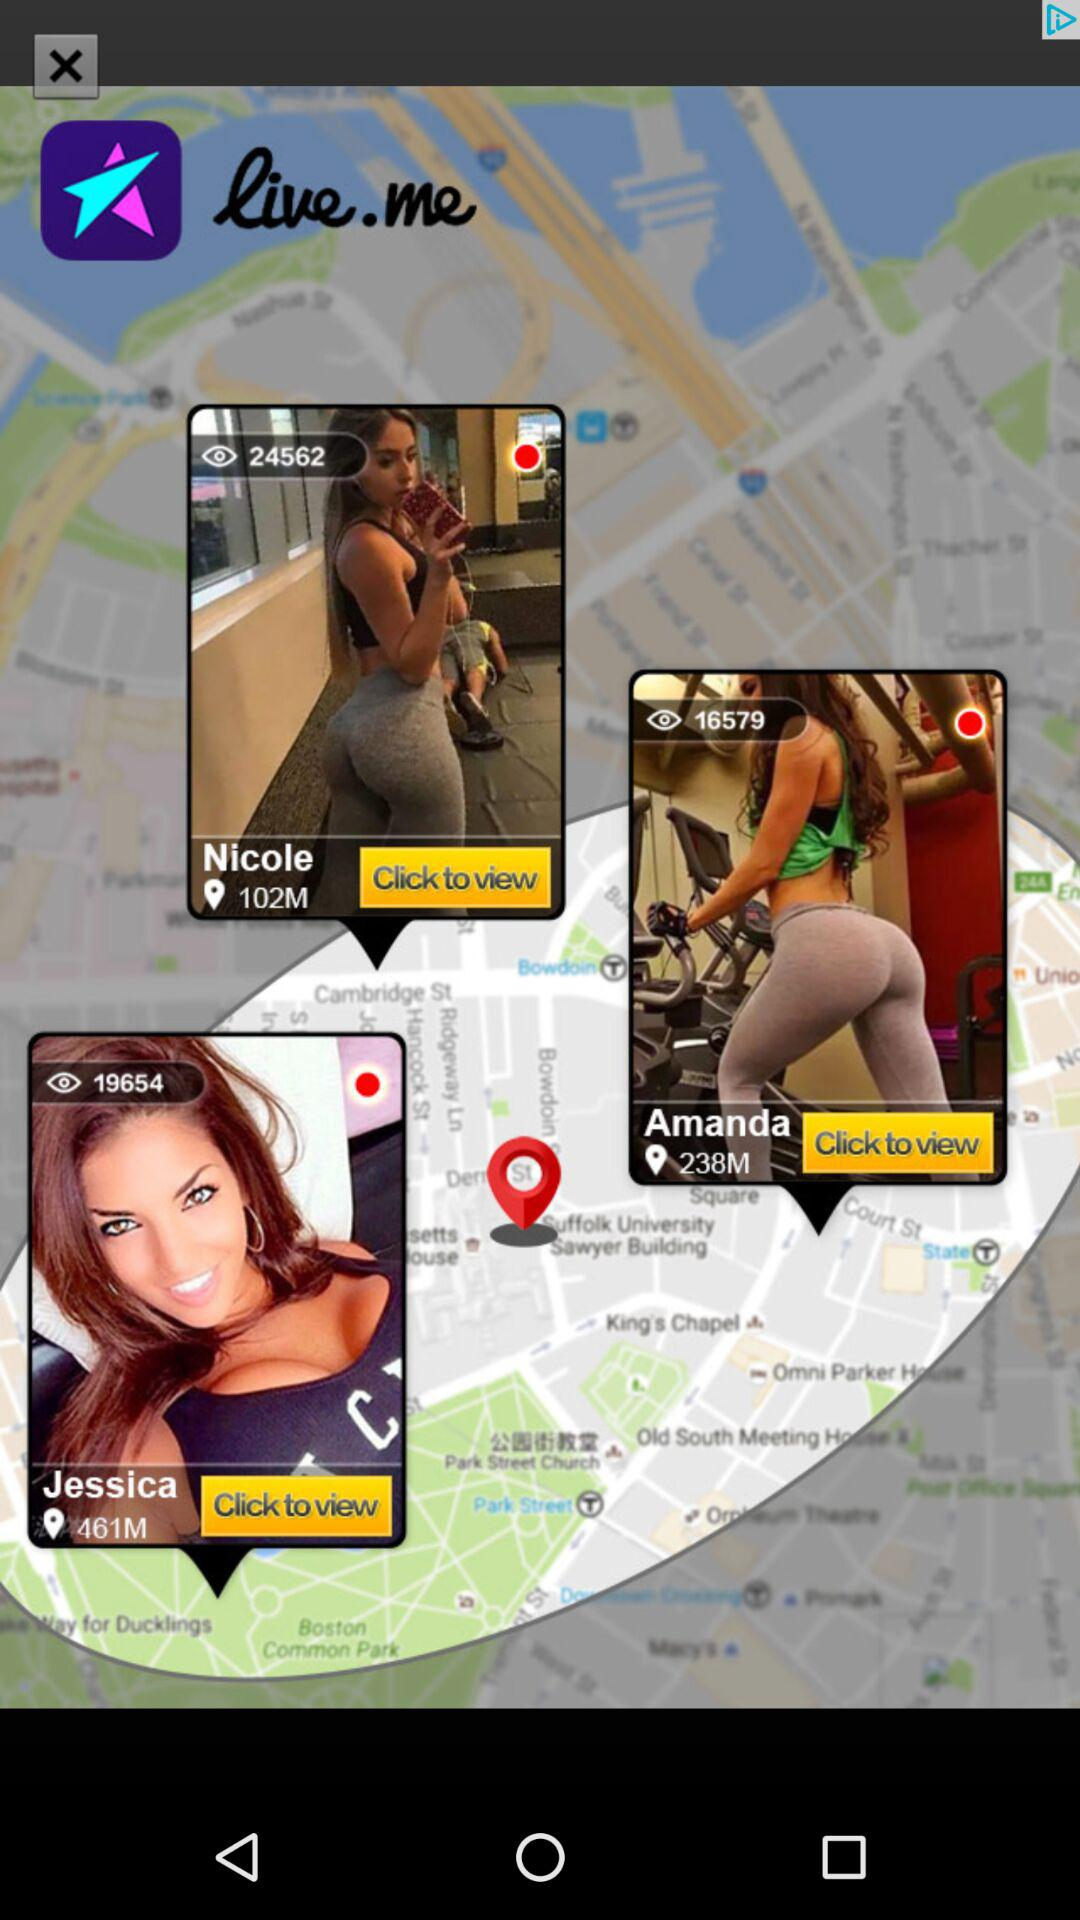Which user has the most views: Nicole or Amanda?
Answer the question using a single word or phrase. Amanda 